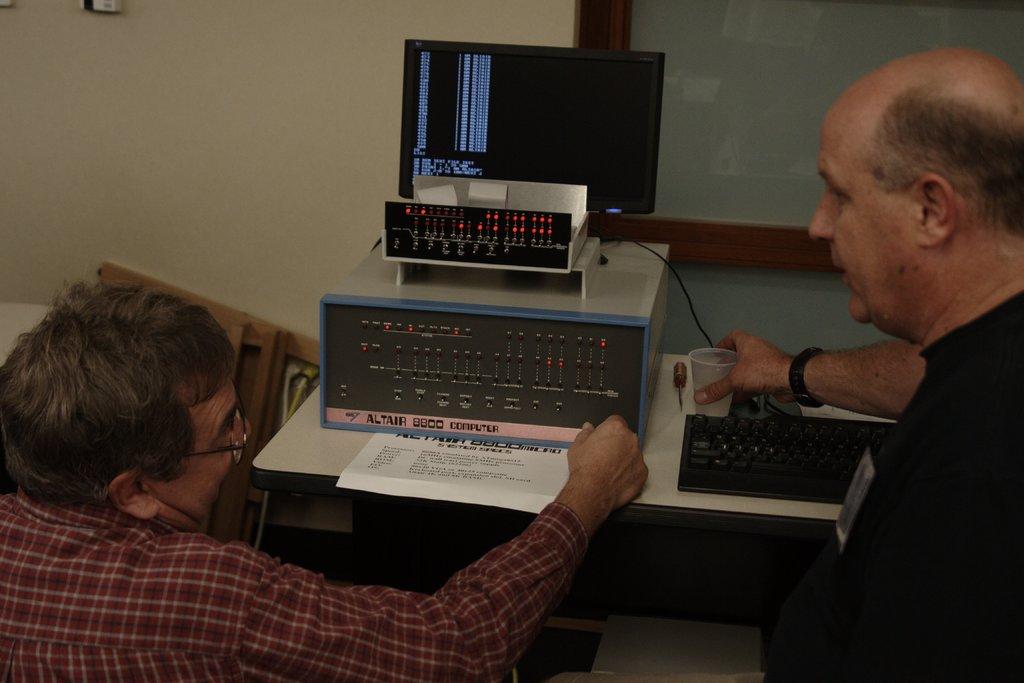What computer are they using?
Keep it short and to the point. Altair 8800. 